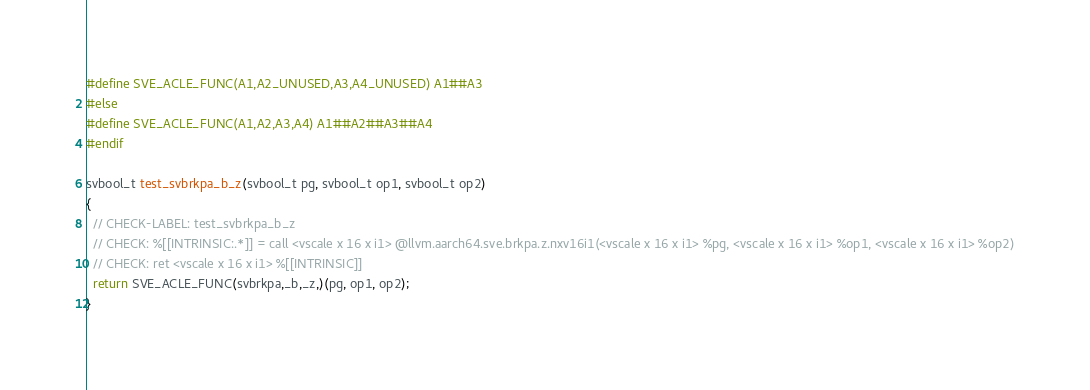<code> <loc_0><loc_0><loc_500><loc_500><_C_>#define SVE_ACLE_FUNC(A1,A2_UNUSED,A3,A4_UNUSED) A1##A3
#else
#define SVE_ACLE_FUNC(A1,A2,A3,A4) A1##A2##A3##A4
#endif

svbool_t test_svbrkpa_b_z(svbool_t pg, svbool_t op1, svbool_t op2)
{
  // CHECK-LABEL: test_svbrkpa_b_z
  // CHECK: %[[INTRINSIC:.*]] = call <vscale x 16 x i1> @llvm.aarch64.sve.brkpa.z.nxv16i1(<vscale x 16 x i1> %pg, <vscale x 16 x i1> %op1, <vscale x 16 x i1> %op2)
  // CHECK: ret <vscale x 16 x i1> %[[INTRINSIC]]
  return SVE_ACLE_FUNC(svbrkpa,_b,_z,)(pg, op1, op2);
}
</code> 